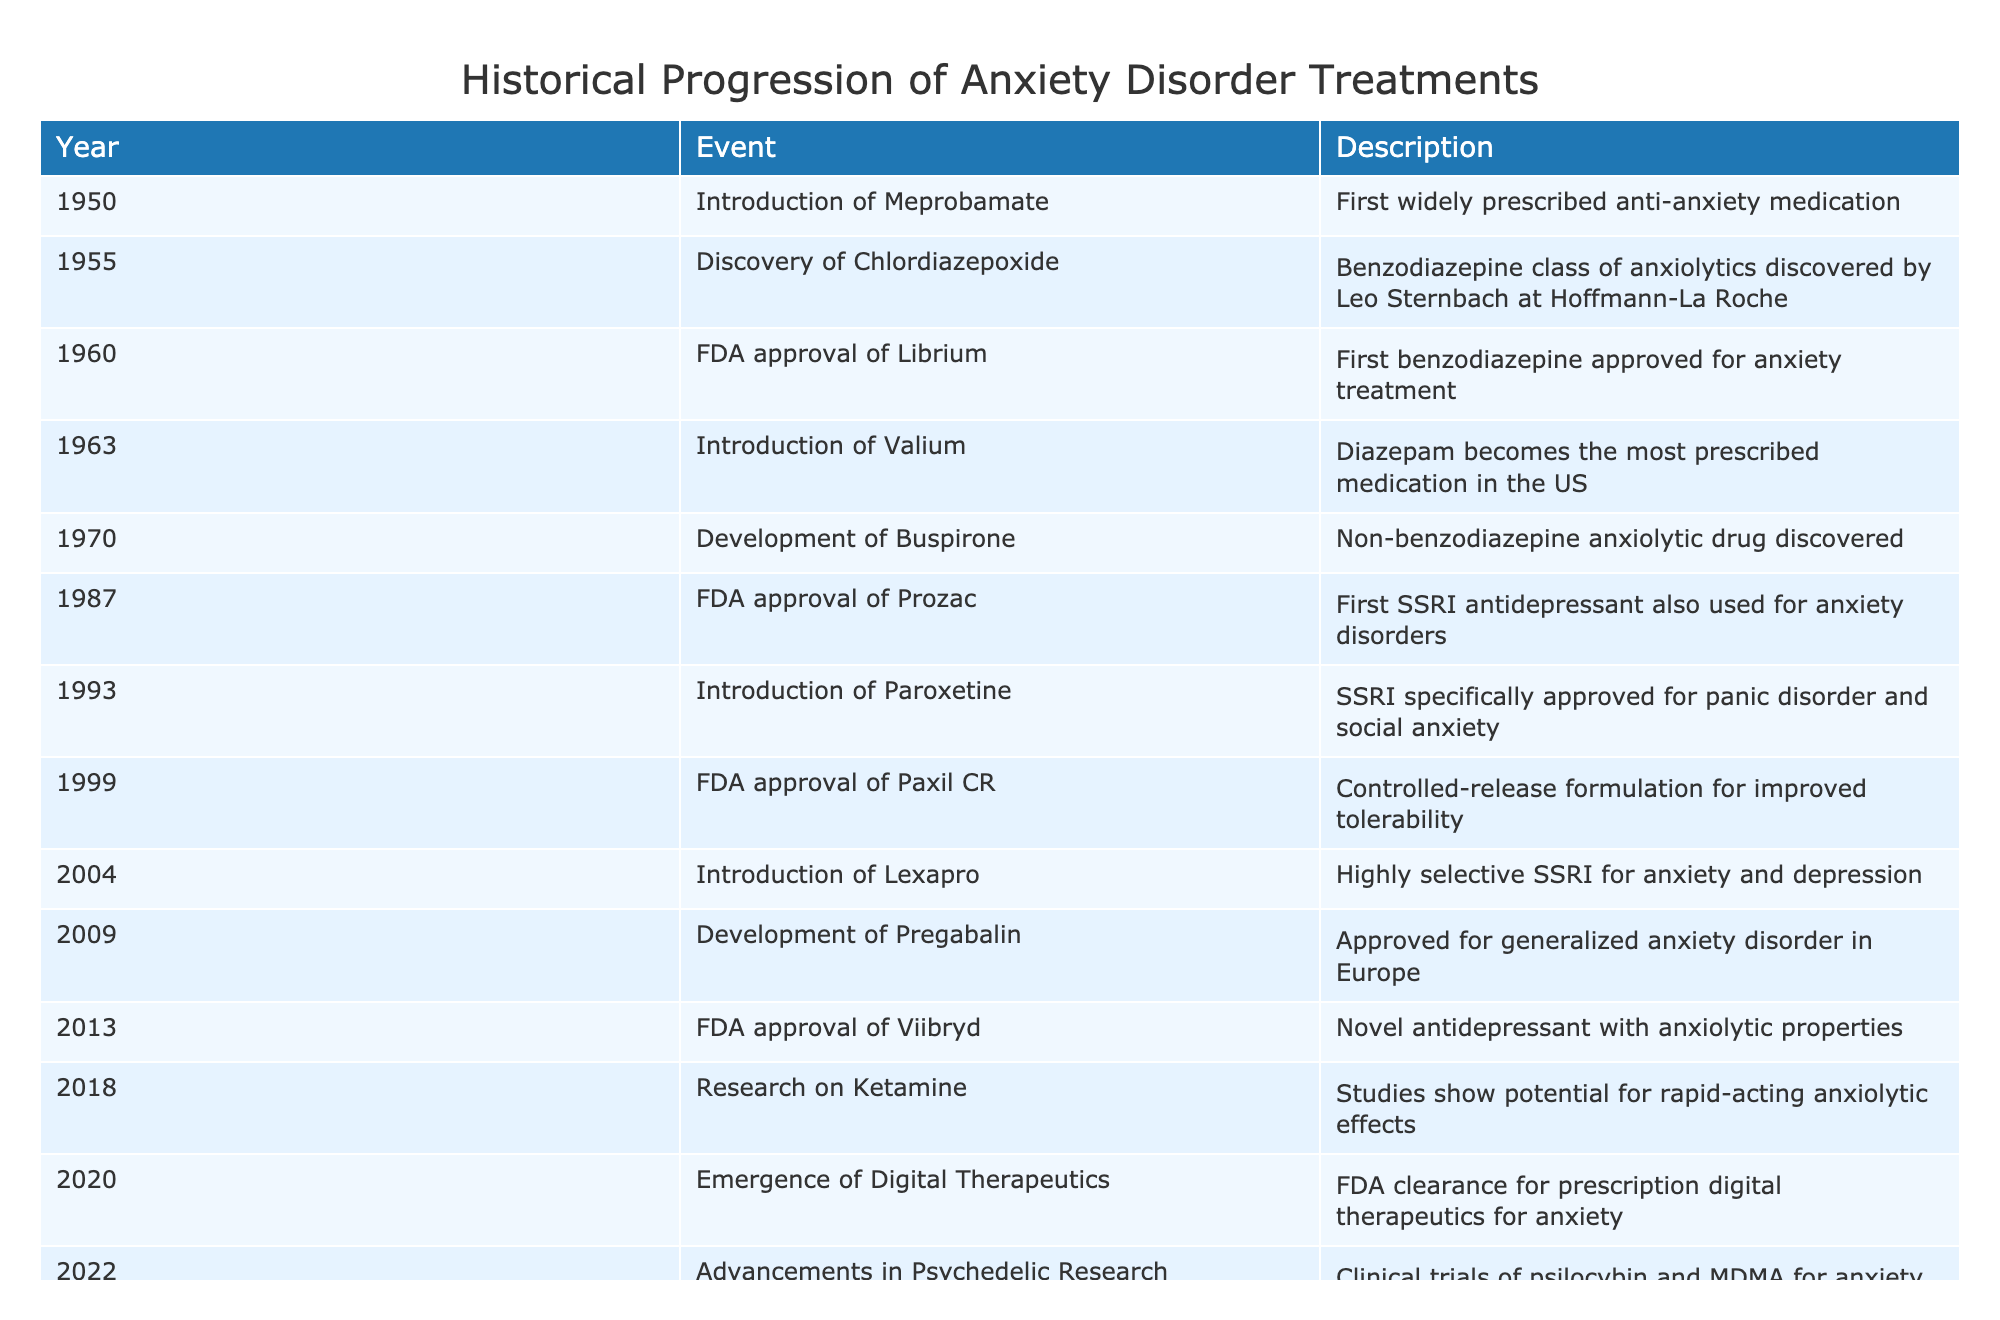What year was Meprobamate introduced? The table indicates that Meprobamate was introduced in 1950. By locating the specific row for Meprobamate, we can easily find its introduction year.
Answer: 1950 Which medication was first FDA approved for anxiety treatment? According to the table, Librium was the first benzodiazepine approved for anxiety in 1960. It is specified in the row indicating the FDA approval of Librium.
Answer: Librium How many years were there between the introduction of Meprobamate and the FDA approval of Prozac? To find this, we look at the years associated with Meprobamate (1950) and Prozac (1987). The difference is 1987 - 1950 = 37 years.
Answer: 37 years Was Pregabalin developed before 2010? The table shows that Pregabalin was developed and approved in 2009, which is before 2010. This is determined by examining the specific year listed next to Pregabalin.
Answer: Yes What is the total number of medications introduced or approved from 1950 to 2004? By inspecting the table, we count the entries from 1950 to 2004, which totals 8 events. This requires counting each row sequentially and ensuring the timeframe includes all relevant medications.
Answer: 8 What happened in 2018 related to anxiety disorder treatments? The table shows that 2018 was marked by research on Ketamine, which demonstrated potential for rapid-acting anxiolytic effects. This can be identified by locating the corresponding row for that year.
Answer: Research on Ketamine Which medication had a controlled-release formulation approved, and when? The table indicates that Paxil CR, a controlled-release formulation, received FDA approval in 1999. This is found in the row indicating Paxil CR.
Answer: Paxil CR, 1999 What is the trend in the development of anxiety disorder treatments from the 1950s to the 2020s? Analyzing the table, there is a notable increase in the introduction of diverse medications, shifting from benzodiazepines to SSRIs, non-benzodiazepines, and modern treatments like digital therapeutics and psychedelics over the decades. This trend demonstrates a broader approach to anxiety disorder treatment.
Answer: Increase in treatment diversity and methods 